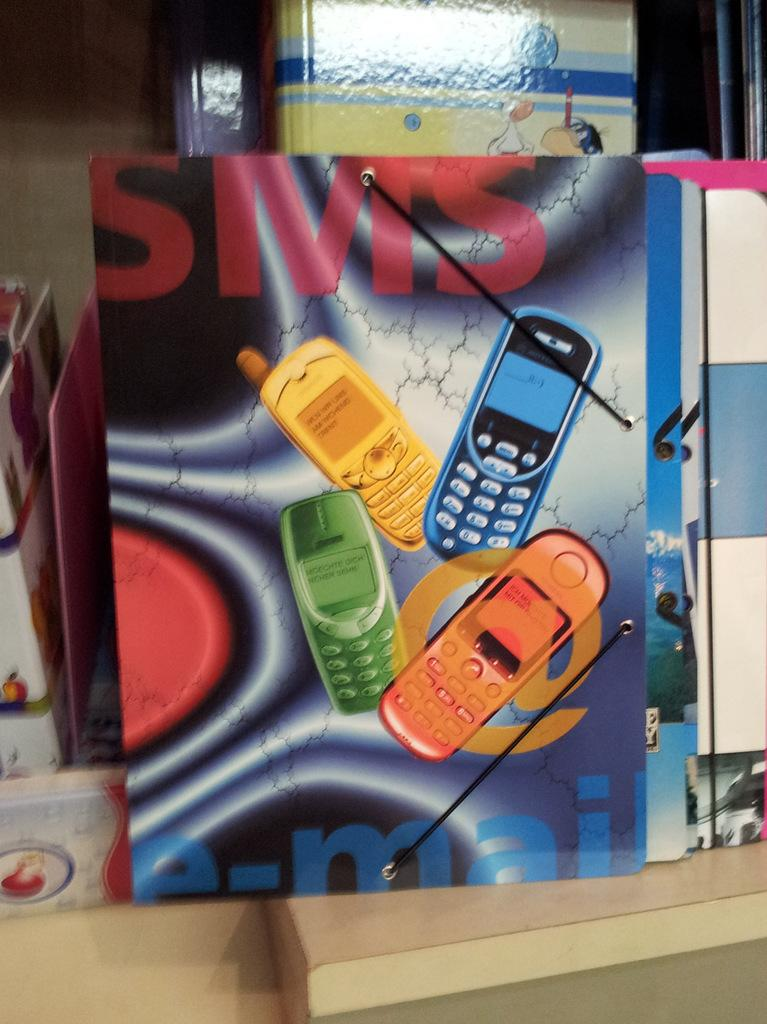<image>
Share a concise interpretation of the image provided. A folder with a picture of four cellphone and the word SMS on top of the phones. 